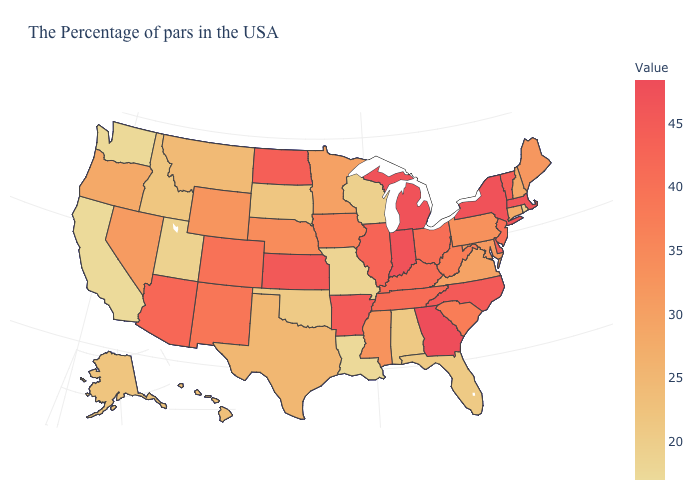Among the states that border Michigan , does Indiana have the highest value?
Give a very brief answer. Yes. Among the states that border Georgia , does South Carolina have the lowest value?
Write a very short answer. No. Does the map have missing data?
Answer briefly. No. Does Georgia have the highest value in the South?
Quick response, please. Yes. Among the states that border West Virginia , which have the lowest value?
Write a very short answer. Virginia. Does the map have missing data?
Write a very short answer. No. Which states have the highest value in the USA?
Answer briefly. Georgia. Which states hav the highest value in the MidWest?
Give a very brief answer. Indiana. 